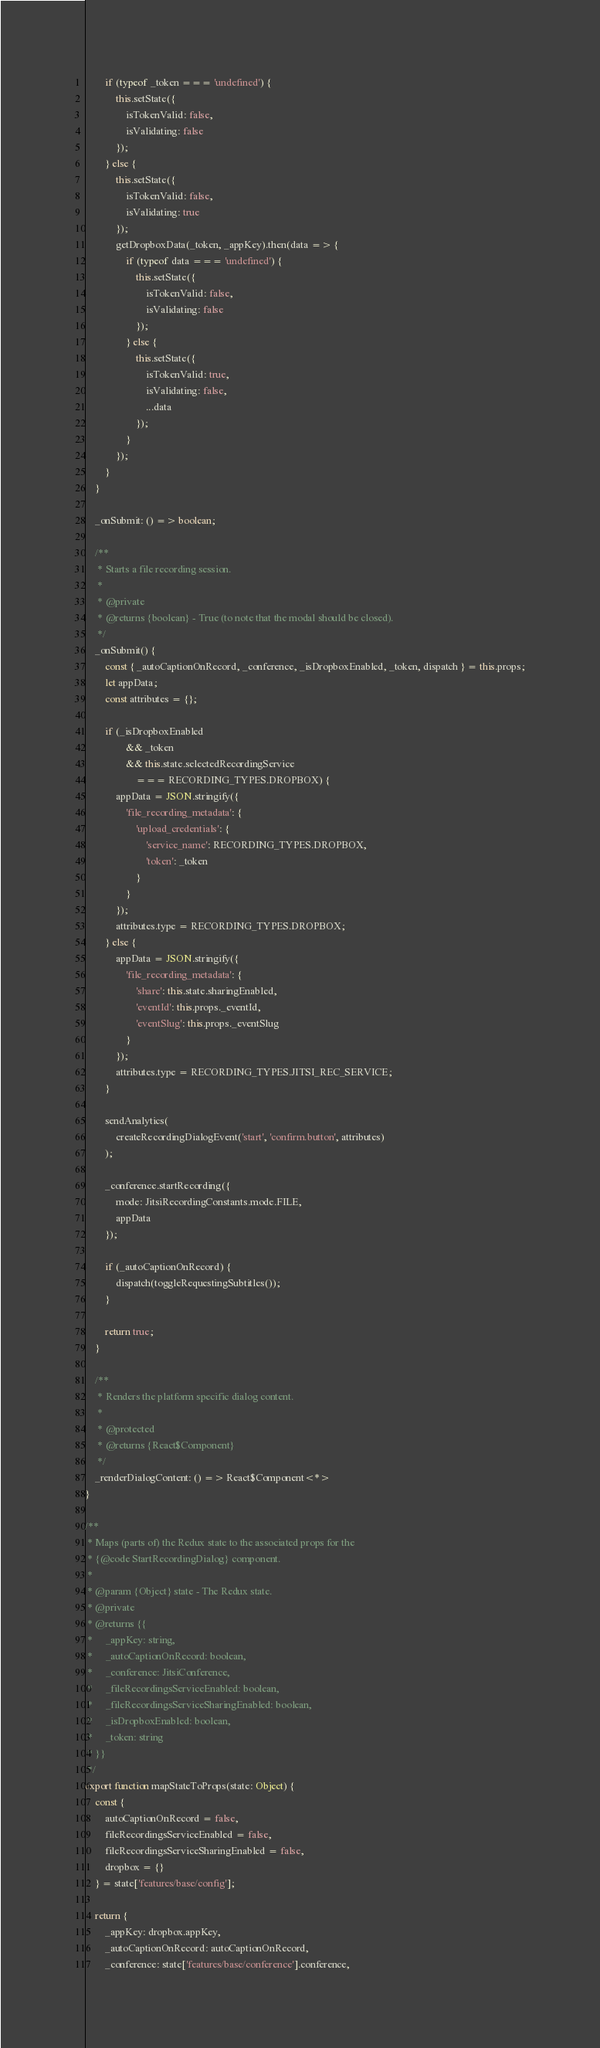<code> <loc_0><loc_0><loc_500><loc_500><_JavaScript_>        if (typeof _token === 'undefined') {
            this.setState({
                isTokenValid: false,
                isValidating: false
            });
        } else {
            this.setState({
                isTokenValid: false,
                isValidating: true
            });
            getDropboxData(_token, _appKey).then(data => {
                if (typeof data === 'undefined') {
                    this.setState({
                        isTokenValid: false,
                        isValidating: false
                    });
                } else {
                    this.setState({
                        isTokenValid: true,
                        isValidating: false,
                        ...data
                    });
                }
            });
        }
    }

    _onSubmit: () => boolean;

    /**
     * Starts a file recording session.
     *
     * @private
     * @returns {boolean} - True (to note that the modal should be closed).
     */
    _onSubmit() {
        const { _autoCaptionOnRecord, _conference, _isDropboxEnabled, _token, dispatch } = this.props;
        let appData;
        const attributes = {};

        if (_isDropboxEnabled
                && _token
                && this.state.selectedRecordingService
                    === RECORDING_TYPES.DROPBOX) {
            appData = JSON.stringify({
                'file_recording_metadata': {
                    'upload_credentials': {
                        'service_name': RECORDING_TYPES.DROPBOX,
                        'token': _token
                    }
                }
            });
            attributes.type = RECORDING_TYPES.DROPBOX;
        } else {
            appData = JSON.stringify({
                'file_recording_metadata': {
                    'share': this.state.sharingEnabled,
                    'eventId': this.props._eventId,
                    'eventSlug': this.props._eventSlug
                }
            });
            attributes.type = RECORDING_TYPES.JITSI_REC_SERVICE;
        }

        sendAnalytics(
            createRecordingDialogEvent('start', 'confirm.button', attributes)
        );

        _conference.startRecording({
            mode: JitsiRecordingConstants.mode.FILE,
            appData
        });

        if (_autoCaptionOnRecord) {
            dispatch(toggleRequestingSubtitles());
        }

        return true;
    }

    /**
     * Renders the platform specific dialog content.
     *
     * @protected
     * @returns {React$Component}
     */
    _renderDialogContent: () => React$Component<*>
}

/**
 * Maps (parts of) the Redux state to the associated props for the
 * {@code StartRecordingDialog} component.
 *
 * @param {Object} state - The Redux state.
 * @private
 * @returns {{
 *     _appKey: string,
 *     _autoCaptionOnRecord: boolean,
 *     _conference: JitsiConference,
 *     _fileRecordingsServiceEnabled: boolean,
 *     _fileRecordingsServiceSharingEnabled: boolean,
 *     _isDropboxEnabled: boolean,
 *     _token: string
 * }}
 */
export function mapStateToProps(state: Object) {
    const {
        autoCaptionOnRecord = false,
        fileRecordingsServiceEnabled = false,
        fileRecordingsServiceSharingEnabled = false,
        dropbox = {}
    } = state['features/base/config'];

    return {
        _appKey: dropbox.appKey,
        _autoCaptionOnRecord: autoCaptionOnRecord,
        _conference: state['features/base/conference'].conference,</code> 